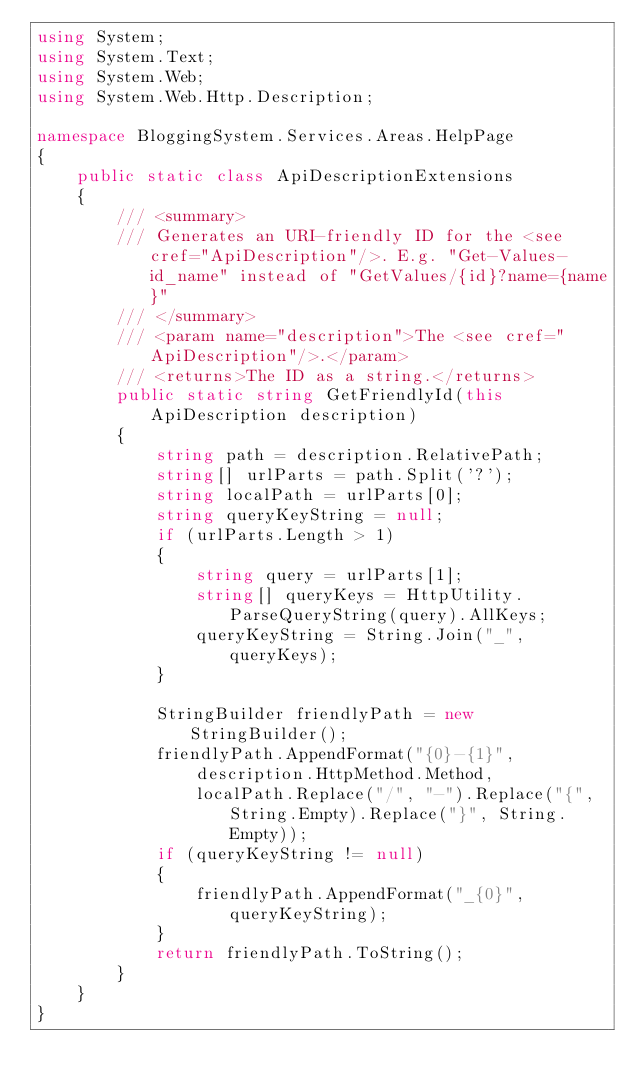<code> <loc_0><loc_0><loc_500><loc_500><_C#_>using System;
using System.Text;
using System.Web;
using System.Web.Http.Description;

namespace BloggingSystem.Services.Areas.HelpPage
{
    public static class ApiDescriptionExtensions
    {
        /// <summary>
        /// Generates an URI-friendly ID for the <see cref="ApiDescription"/>. E.g. "Get-Values-id_name" instead of "GetValues/{id}?name={name}"
        /// </summary>
        /// <param name="description">The <see cref="ApiDescription"/>.</param>
        /// <returns>The ID as a string.</returns>
        public static string GetFriendlyId(this ApiDescription description)
        {
            string path = description.RelativePath;
            string[] urlParts = path.Split('?');
            string localPath = urlParts[0];
            string queryKeyString = null;
            if (urlParts.Length > 1)
            {
                string query = urlParts[1];
                string[] queryKeys = HttpUtility.ParseQueryString(query).AllKeys;
                queryKeyString = String.Join("_", queryKeys);
            }

            StringBuilder friendlyPath = new StringBuilder();
            friendlyPath.AppendFormat("{0}-{1}",
                description.HttpMethod.Method,
                localPath.Replace("/", "-").Replace("{", String.Empty).Replace("}", String.Empty));
            if (queryKeyString != null)
            {
                friendlyPath.AppendFormat("_{0}", queryKeyString);
            }
            return friendlyPath.ToString();
        }
    }
}</code> 